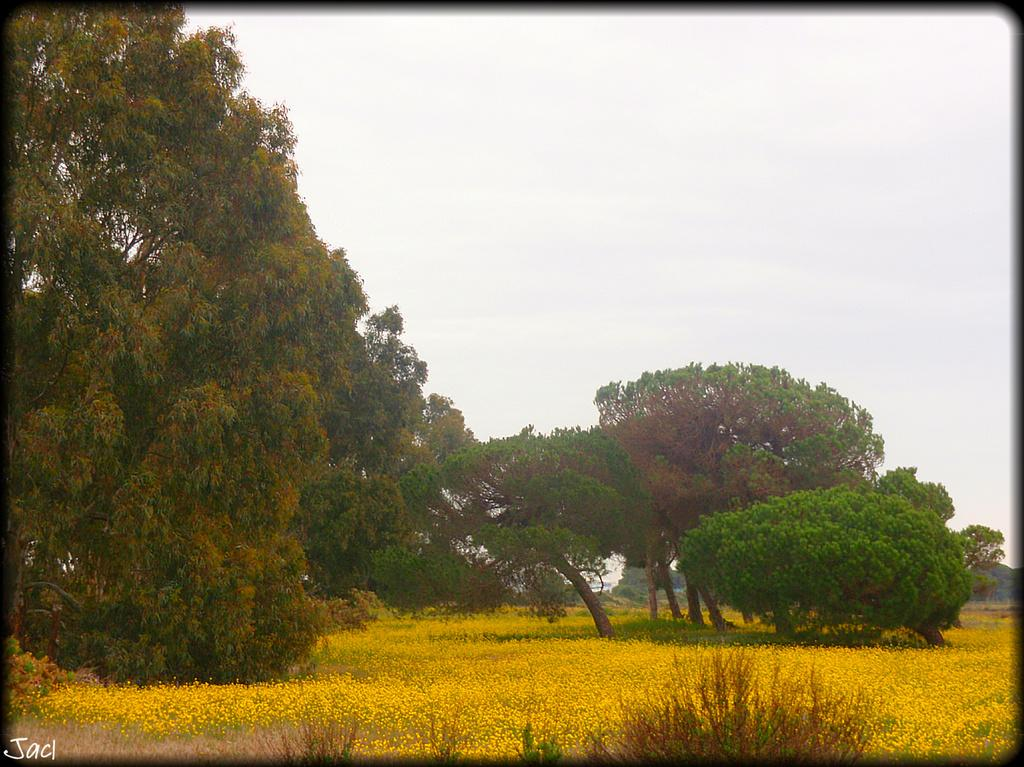What type of vegetation can be seen in the image? There are trees in the image. What is located at the bottom of the image? There are flowers at the bottom of the image. What color are the flowers? The flowers are yellow in color. What can be seen above the trees and flowers in the image? There is a sky visible in the image. What type of shock can be seen affecting the trees in the image? There is no shock present in the image; the trees appear to be unaffected. Is there a bomb visible in the image? There is no bomb present in the image. 